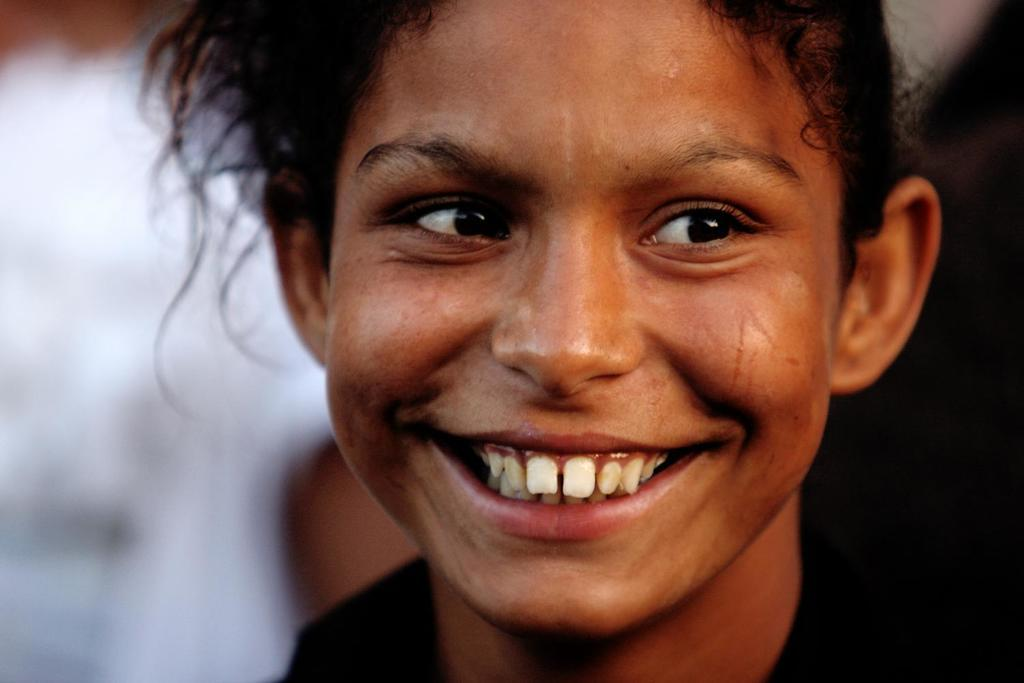What is the main subject in the foreground of the image? There is a girl in the foreground of the image. What expression does the girl have on her face? The girl has a smile on her face. How would you describe the background of the image? The background of the image is blurred. Who is the owner of the burst selection in the image? There is no burst or selection present in the image, so this question cannot be answered. 